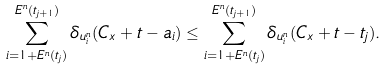<formula> <loc_0><loc_0><loc_500><loc_500>\sum _ { i = 1 + E ^ { n } ( t _ { j } ) } ^ { E ^ { n } ( t _ { j + 1 } ) } \delta _ { u ^ { n } _ { i } } ( C _ { x } + t - a _ { i } ) & \leq \sum _ { i = 1 + E ^ { n } ( t _ { j } ) } ^ { E ^ { n } ( t _ { j + 1 } ) } \delta _ { u ^ { n } _ { i } } ( C _ { x } + t - t _ { j } ) .</formula> 